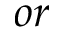Convert formula to latex. <formula><loc_0><loc_0><loc_500><loc_500>o r</formula> 